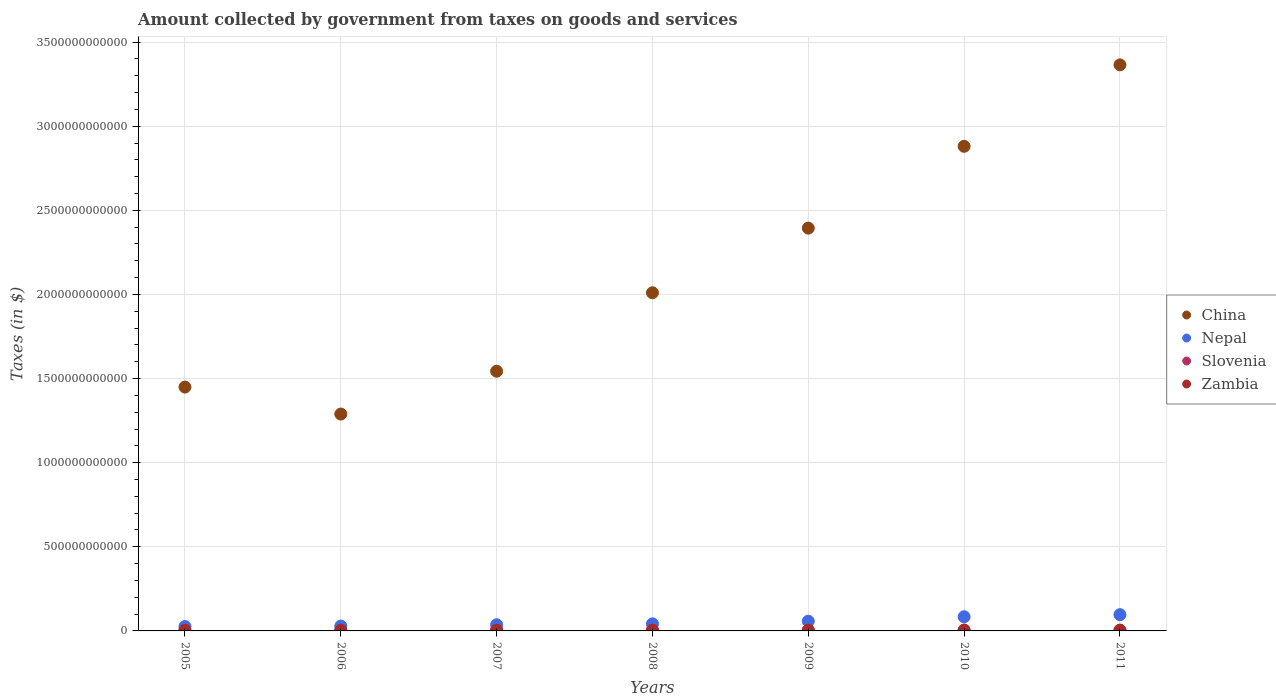What is the amount collected by government from taxes on goods and services in China in 2006?
Keep it short and to the point. 1.29e+12. Across all years, what is the maximum amount collected by government from taxes on goods and services in Slovenia?
Ensure brevity in your answer.  4.73e+09. Across all years, what is the minimum amount collected by government from taxes on goods and services in Nepal?
Give a very brief answer. 2.61e+1. In which year was the amount collected by government from taxes on goods and services in Nepal maximum?
Ensure brevity in your answer.  2011. What is the total amount collected by government from taxes on goods and services in Zambia in the graph?
Make the answer very short. 2.54e+1. What is the difference between the amount collected by government from taxes on goods and services in Zambia in 2010 and that in 2011?
Give a very brief answer. 9.21e+08. What is the difference between the amount collected by government from taxes on goods and services in China in 2011 and the amount collected by government from taxes on goods and services in Zambia in 2005?
Ensure brevity in your answer.  3.36e+12. What is the average amount collected by government from taxes on goods and services in Slovenia per year?
Give a very brief answer. 4.39e+09. In the year 2005, what is the difference between the amount collected by government from taxes on goods and services in China and amount collected by government from taxes on goods and services in Slovenia?
Your answer should be compact. 1.45e+12. In how many years, is the amount collected by government from taxes on goods and services in Zambia greater than 2800000000000 $?
Offer a very short reply. 0. What is the ratio of the amount collected by government from taxes on goods and services in China in 2005 to that in 2009?
Your answer should be very brief. 0.61. Is the amount collected by government from taxes on goods and services in Zambia in 2005 less than that in 2008?
Make the answer very short. Yes. What is the difference between the highest and the second highest amount collected by government from taxes on goods and services in China?
Ensure brevity in your answer.  4.84e+11. What is the difference between the highest and the lowest amount collected by government from taxes on goods and services in Nepal?
Your response must be concise. 7.05e+1. Is the sum of the amount collected by government from taxes on goods and services in Zambia in 2005 and 2008 greater than the maximum amount collected by government from taxes on goods and services in China across all years?
Your answer should be very brief. No. Is it the case that in every year, the sum of the amount collected by government from taxes on goods and services in China and amount collected by government from taxes on goods and services in Nepal  is greater than the sum of amount collected by government from taxes on goods and services in Zambia and amount collected by government from taxes on goods and services in Slovenia?
Give a very brief answer. Yes. Is the amount collected by government from taxes on goods and services in Nepal strictly less than the amount collected by government from taxes on goods and services in Slovenia over the years?
Offer a terse response. No. How many years are there in the graph?
Offer a terse response. 7. What is the difference between two consecutive major ticks on the Y-axis?
Your answer should be compact. 5.00e+11. Are the values on the major ticks of Y-axis written in scientific E-notation?
Your answer should be compact. No. Does the graph contain grids?
Provide a short and direct response. Yes. Where does the legend appear in the graph?
Ensure brevity in your answer.  Center right. How many legend labels are there?
Offer a very short reply. 4. What is the title of the graph?
Provide a short and direct response. Amount collected by government from taxes on goods and services. What is the label or title of the X-axis?
Your answer should be compact. Years. What is the label or title of the Y-axis?
Make the answer very short. Taxes (in $). What is the Taxes (in $) of China in 2005?
Your answer should be compact. 1.45e+12. What is the Taxes (in $) in Nepal in 2005?
Ensure brevity in your answer.  2.61e+1. What is the Taxes (in $) of Slovenia in 2005?
Provide a succinct answer. 3.78e+09. What is the Taxes (in $) of Zambia in 2005?
Offer a terse response. 2.34e+09. What is the Taxes (in $) of China in 2006?
Ensure brevity in your answer.  1.29e+12. What is the Taxes (in $) in Nepal in 2006?
Your answer should be very brief. 2.90e+1. What is the Taxes (in $) of Slovenia in 2006?
Offer a terse response. 3.95e+09. What is the Taxes (in $) of Zambia in 2006?
Your answer should be compact. 2.66e+09. What is the Taxes (in $) of China in 2007?
Your answer should be compact. 1.54e+12. What is the Taxes (in $) in Nepal in 2007?
Your answer should be compact. 3.64e+1. What is the Taxes (in $) of Slovenia in 2007?
Your answer should be very brief. 4.37e+09. What is the Taxes (in $) in Zambia in 2007?
Provide a short and direct response. 3.62e+09. What is the Taxes (in $) of China in 2008?
Provide a short and direct response. 2.01e+12. What is the Taxes (in $) in Nepal in 2008?
Provide a short and direct response. 4.21e+1. What is the Taxes (in $) in Slovenia in 2008?
Offer a terse response. 4.67e+09. What is the Taxes (in $) of Zambia in 2008?
Provide a succinct answer. 4.11e+09. What is the Taxes (in $) of China in 2009?
Ensure brevity in your answer.  2.39e+12. What is the Taxes (in $) of Nepal in 2009?
Your response must be concise. 5.78e+1. What is the Taxes (in $) of Slovenia in 2009?
Your answer should be compact. 4.54e+09. What is the Taxes (in $) of Zambia in 2009?
Offer a very short reply. 3.82e+09. What is the Taxes (in $) of China in 2010?
Make the answer very short. 2.88e+12. What is the Taxes (in $) of Nepal in 2010?
Offer a terse response. 8.42e+1. What is the Taxes (in $) in Slovenia in 2010?
Make the answer very short. 4.66e+09. What is the Taxes (in $) of Zambia in 2010?
Keep it short and to the point. 4.90e+09. What is the Taxes (in $) of China in 2011?
Ensure brevity in your answer.  3.36e+12. What is the Taxes (in $) of Nepal in 2011?
Give a very brief answer. 9.67e+1. What is the Taxes (in $) in Slovenia in 2011?
Your answer should be compact. 4.73e+09. What is the Taxes (in $) in Zambia in 2011?
Your answer should be very brief. 3.98e+09. Across all years, what is the maximum Taxes (in $) in China?
Ensure brevity in your answer.  3.36e+12. Across all years, what is the maximum Taxes (in $) in Nepal?
Ensure brevity in your answer.  9.67e+1. Across all years, what is the maximum Taxes (in $) in Slovenia?
Make the answer very short. 4.73e+09. Across all years, what is the maximum Taxes (in $) of Zambia?
Make the answer very short. 4.90e+09. Across all years, what is the minimum Taxes (in $) of China?
Your answer should be very brief. 1.29e+12. Across all years, what is the minimum Taxes (in $) of Nepal?
Make the answer very short. 2.61e+1. Across all years, what is the minimum Taxes (in $) of Slovenia?
Ensure brevity in your answer.  3.78e+09. Across all years, what is the minimum Taxes (in $) of Zambia?
Offer a terse response. 2.34e+09. What is the total Taxes (in $) in China in the graph?
Make the answer very short. 1.49e+13. What is the total Taxes (in $) in Nepal in the graph?
Keep it short and to the point. 3.72e+11. What is the total Taxes (in $) of Slovenia in the graph?
Your answer should be compact. 3.07e+1. What is the total Taxes (in $) of Zambia in the graph?
Your response must be concise. 2.54e+1. What is the difference between the Taxes (in $) of China in 2005 and that in 2006?
Your response must be concise. 1.60e+11. What is the difference between the Taxes (in $) of Nepal in 2005 and that in 2006?
Give a very brief answer. -2.83e+09. What is the difference between the Taxes (in $) in Slovenia in 2005 and that in 2006?
Ensure brevity in your answer.  -1.67e+08. What is the difference between the Taxes (in $) in Zambia in 2005 and that in 2006?
Make the answer very short. -3.15e+08. What is the difference between the Taxes (in $) of China in 2005 and that in 2007?
Ensure brevity in your answer.  -9.43e+1. What is the difference between the Taxes (in $) in Nepal in 2005 and that in 2007?
Give a very brief answer. -1.03e+1. What is the difference between the Taxes (in $) in Slovenia in 2005 and that in 2007?
Your response must be concise. -5.90e+08. What is the difference between the Taxes (in $) in Zambia in 2005 and that in 2007?
Offer a very short reply. -1.28e+09. What is the difference between the Taxes (in $) in China in 2005 and that in 2008?
Provide a succinct answer. -5.61e+11. What is the difference between the Taxes (in $) in Nepal in 2005 and that in 2008?
Give a very brief answer. -1.59e+1. What is the difference between the Taxes (in $) of Slovenia in 2005 and that in 2008?
Give a very brief answer. -8.86e+08. What is the difference between the Taxes (in $) of Zambia in 2005 and that in 2008?
Your answer should be compact. -1.77e+09. What is the difference between the Taxes (in $) of China in 2005 and that in 2009?
Your answer should be very brief. -9.45e+11. What is the difference between the Taxes (in $) in Nepal in 2005 and that in 2009?
Provide a short and direct response. -3.16e+1. What is the difference between the Taxes (in $) of Slovenia in 2005 and that in 2009?
Make the answer very short. -7.59e+08. What is the difference between the Taxes (in $) in Zambia in 2005 and that in 2009?
Your answer should be compact. -1.48e+09. What is the difference between the Taxes (in $) in China in 2005 and that in 2010?
Give a very brief answer. -1.43e+12. What is the difference between the Taxes (in $) of Nepal in 2005 and that in 2010?
Provide a succinct answer. -5.80e+1. What is the difference between the Taxes (in $) of Slovenia in 2005 and that in 2010?
Offer a terse response. -8.77e+08. What is the difference between the Taxes (in $) in Zambia in 2005 and that in 2010?
Give a very brief answer. -2.56e+09. What is the difference between the Taxes (in $) in China in 2005 and that in 2011?
Your answer should be very brief. -1.92e+12. What is the difference between the Taxes (in $) of Nepal in 2005 and that in 2011?
Your response must be concise. -7.05e+1. What is the difference between the Taxes (in $) in Slovenia in 2005 and that in 2011?
Keep it short and to the point. -9.50e+08. What is the difference between the Taxes (in $) in Zambia in 2005 and that in 2011?
Your answer should be compact. -1.64e+09. What is the difference between the Taxes (in $) in China in 2006 and that in 2007?
Your response must be concise. -2.55e+11. What is the difference between the Taxes (in $) in Nepal in 2006 and that in 2007?
Your answer should be compact. -7.46e+09. What is the difference between the Taxes (in $) in Slovenia in 2006 and that in 2007?
Offer a very short reply. -4.23e+08. What is the difference between the Taxes (in $) in Zambia in 2006 and that in 2007?
Give a very brief answer. -9.62e+08. What is the difference between the Taxes (in $) in China in 2006 and that in 2008?
Offer a terse response. -7.21e+11. What is the difference between the Taxes (in $) in Nepal in 2006 and that in 2008?
Your answer should be very brief. -1.31e+1. What is the difference between the Taxes (in $) of Slovenia in 2006 and that in 2008?
Provide a short and direct response. -7.19e+08. What is the difference between the Taxes (in $) in Zambia in 2006 and that in 2008?
Give a very brief answer. -1.46e+09. What is the difference between the Taxes (in $) of China in 2006 and that in 2009?
Your answer should be very brief. -1.11e+12. What is the difference between the Taxes (in $) of Nepal in 2006 and that in 2009?
Ensure brevity in your answer.  -2.88e+1. What is the difference between the Taxes (in $) in Slovenia in 2006 and that in 2009?
Make the answer very short. -5.92e+08. What is the difference between the Taxes (in $) of Zambia in 2006 and that in 2009?
Make the answer very short. -1.17e+09. What is the difference between the Taxes (in $) of China in 2006 and that in 2010?
Provide a short and direct response. -1.59e+12. What is the difference between the Taxes (in $) of Nepal in 2006 and that in 2010?
Give a very brief answer. -5.52e+1. What is the difference between the Taxes (in $) of Slovenia in 2006 and that in 2010?
Offer a very short reply. -7.09e+08. What is the difference between the Taxes (in $) in Zambia in 2006 and that in 2010?
Your answer should be very brief. -2.24e+09. What is the difference between the Taxes (in $) in China in 2006 and that in 2011?
Your response must be concise. -2.08e+12. What is the difference between the Taxes (in $) in Nepal in 2006 and that in 2011?
Your response must be concise. -6.77e+1. What is the difference between the Taxes (in $) of Slovenia in 2006 and that in 2011?
Offer a terse response. -7.83e+08. What is the difference between the Taxes (in $) in Zambia in 2006 and that in 2011?
Give a very brief answer. -1.32e+09. What is the difference between the Taxes (in $) of China in 2007 and that in 2008?
Provide a short and direct response. -4.66e+11. What is the difference between the Taxes (in $) in Nepal in 2007 and that in 2008?
Provide a short and direct response. -5.64e+09. What is the difference between the Taxes (in $) in Slovenia in 2007 and that in 2008?
Ensure brevity in your answer.  -2.96e+08. What is the difference between the Taxes (in $) of Zambia in 2007 and that in 2008?
Provide a succinct answer. -4.95e+08. What is the difference between the Taxes (in $) of China in 2007 and that in 2009?
Provide a succinct answer. -8.50e+11. What is the difference between the Taxes (in $) in Nepal in 2007 and that in 2009?
Your answer should be very brief. -2.13e+1. What is the difference between the Taxes (in $) of Slovenia in 2007 and that in 2009?
Provide a succinct answer. -1.69e+08. What is the difference between the Taxes (in $) in Zambia in 2007 and that in 2009?
Your answer should be compact. -2.04e+08. What is the difference between the Taxes (in $) in China in 2007 and that in 2010?
Make the answer very short. -1.34e+12. What is the difference between the Taxes (in $) in Nepal in 2007 and that in 2010?
Make the answer very short. -4.77e+1. What is the difference between the Taxes (in $) of Slovenia in 2007 and that in 2010?
Give a very brief answer. -2.86e+08. What is the difference between the Taxes (in $) in Zambia in 2007 and that in 2010?
Offer a very short reply. -1.28e+09. What is the difference between the Taxes (in $) of China in 2007 and that in 2011?
Your answer should be very brief. -1.82e+12. What is the difference between the Taxes (in $) of Nepal in 2007 and that in 2011?
Offer a terse response. -6.02e+1. What is the difference between the Taxes (in $) of Slovenia in 2007 and that in 2011?
Provide a succinct answer. -3.60e+08. What is the difference between the Taxes (in $) of Zambia in 2007 and that in 2011?
Make the answer very short. -3.62e+08. What is the difference between the Taxes (in $) in China in 2008 and that in 2009?
Your response must be concise. -3.84e+11. What is the difference between the Taxes (in $) in Nepal in 2008 and that in 2009?
Offer a very short reply. -1.57e+1. What is the difference between the Taxes (in $) of Slovenia in 2008 and that in 2009?
Make the answer very short. 1.27e+08. What is the difference between the Taxes (in $) of Zambia in 2008 and that in 2009?
Ensure brevity in your answer.  2.91e+08. What is the difference between the Taxes (in $) in China in 2008 and that in 2010?
Ensure brevity in your answer.  -8.70e+11. What is the difference between the Taxes (in $) in Nepal in 2008 and that in 2010?
Give a very brief answer. -4.21e+1. What is the difference between the Taxes (in $) in Slovenia in 2008 and that in 2010?
Provide a succinct answer. 9.21e+06. What is the difference between the Taxes (in $) of Zambia in 2008 and that in 2010?
Your answer should be very brief. -7.88e+08. What is the difference between the Taxes (in $) of China in 2008 and that in 2011?
Ensure brevity in your answer.  -1.35e+12. What is the difference between the Taxes (in $) of Nepal in 2008 and that in 2011?
Offer a terse response. -5.46e+1. What is the difference between the Taxes (in $) in Slovenia in 2008 and that in 2011?
Your answer should be compact. -6.41e+07. What is the difference between the Taxes (in $) of Zambia in 2008 and that in 2011?
Keep it short and to the point. 1.33e+08. What is the difference between the Taxes (in $) of China in 2009 and that in 2010?
Your response must be concise. -4.86e+11. What is the difference between the Taxes (in $) in Nepal in 2009 and that in 2010?
Ensure brevity in your answer.  -2.64e+1. What is the difference between the Taxes (in $) of Slovenia in 2009 and that in 2010?
Offer a terse response. -1.17e+08. What is the difference between the Taxes (in $) of Zambia in 2009 and that in 2010?
Provide a short and direct response. -1.08e+09. What is the difference between the Taxes (in $) in China in 2009 and that in 2011?
Offer a very short reply. -9.71e+11. What is the difference between the Taxes (in $) of Nepal in 2009 and that in 2011?
Your response must be concise. -3.89e+1. What is the difference between the Taxes (in $) in Slovenia in 2009 and that in 2011?
Your answer should be compact. -1.91e+08. What is the difference between the Taxes (in $) of Zambia in 2009 and that in 2011?
Keep it short and to the point. -1.58e+08. What is the difference between the Taxes (in $) in China in 2010 and that in 2011?
Provide a short and direct response. -4.84e+11. What is the difference between the Taxes (in $) of Nepal in 2010 and that in 2011?
Provide a succinct answer. -1.25e+1. What is the difference between the Taxes (in $) of Slovenia in 2010 and that in 2011?
Provide a succinct answer. -7.33e+07. What is the difference between the Taxes (in $) of Zambia in 2010 and that in 2011?
Your answer should be compact. 9.21e+08. What is the difference between the Taxes (in $) in China in 2005 and the Taxes (in $) in Nepal in 2006?
Offer a terse response. 1.42e+12. What is the difference between the Taxes (in $) of China in 2005 and the Taxes (in $) of Slovenia in 2006?
Ensure brevity in your answer.  1.45e+12. What is the difference between the Taxes (in $) of China in 2005 and the Taxes (in $) of Zambia in 2006?
Keep it short and to the point. 1.45e+12. What is the difference between the Taxes (in $) of Nepal in 2005 and the Taxes (in $) of Slovenia in 2006?
Provide a succinct answer. 2.22e+1. What is the difference between the Taxes (in $) in Nepal in 2005 and the Taxes (in $) in Zambia in 2006?
Your answer should be compact. 2.35e+1. What is the difference between the Taxes (in $) in Slovenia in 2005 and the Taxes (in $) in Zambia in 2006?
Your answer should be very brief. 1.13e+09. What is the difference between the Taxes (in $) in China in 2005 and the Taxes (in $) in Nepal in 2007?
Make the answer very short. 1.41e+12. What is the difference between the Taxes (in $) of China in 2005 and the Taxes (in $) of Slovenia in 2007?
Offer a terse response. 1.45e+12. What is the difference between the Taxes (in $) in China in 2005 and the Taxes (in $) in Zambia in 2007?
Provide a succinct answer. 1.45e+12. What is the difference between the Taxes (in $) of Nepal in 2005 and the Taxes (in $) of Slovenia in 2007?
Your answer should be very brief. 2.18e+1. What is the difference between the Taxes (in $) in Nepal in 2005 and the Taxes (in $) in Zambia in 2007?
Ensure brevity in your answer.  2.25e+1. What is the difference between the Taxes (in $) in Slovenia in 2005 and the Taxes (in $) in Zambia in 2007?
Keep it short and to the point. 1.65e+08. What is the difference between the Taxes (in $) in China in 2005 and the Taxes (in $) in Nepal in 2008?
Make the answer very short. 1.41e+12. What is the difference between the Taxes (in $) in China in 2005 and the Taxes (in $) in Slovenia in 2008?
Keep it short and to the point. 1.44e+12. What is the difference between the Taxes (in $) in China in 2005 and the Taxes (in $) in Zambia in 2008?
Keep it short and to the point. 1.45e+12. What is the difference between the Taxes (in $) of Nepal in 2005 and the Taxes (in $) of Slovenia in 2008?
Keep it short and to the point. 2.15e+1. What is the difference between the Taxes (in $) in Nepal in 2005 and the Taxes (in $) in Zambia in 2008?
Offer a very short reply. 2.20e+1. What is the difference between the Taxes (in $) in Slovenia in 2005 and the Taxes (in $) in Zambia in 2008?
Offer a very short reply. -3.30e+08. What is the difference between the Taxes (in $) in China in 2005 and the Taxes (in $) in Nepal in 2009?
Provide a succinct answer. 1.39e+12. What is the difference between the Taxes (in $) in China in 2005 and the Taxes (in $) in Slovenia in 2009?
Your answer should be very brief. 1.44e+12. What is the difference between the Taxes (in $) in China in 2005 and the Taxes (in $) in Zambia in 2009?
Ensure brevity in your answer.  1.45e+12. What is the difference between the Taxes (in $) of Nepal in 2005 and the Taxes (in $) of Slovenia in 2009?
Make the answer very short. 2.16e+1. What is the difference between the Taxes (in $) in Nepal in 2005 and the Taxes (in $) in Zambia in 2009?
Ensure brevity in your answer.  2.23e+1. What is the difference between the Taxes (in $) of Slovenia in 2005 and the Taxes (in $) of Zambia in 2009?
Your response must be concise. -3.88e+07. What is the difference between the Taxes (in $) in China in 2005 and the Taxes (in $) in Nepal in 2010?
Keep it short and to the point. 1.37e+12. What is the difference between the Taxes (in $) in China in 2005 and the Taxes (in $) in Slovenia in 2010?
Your answer should be compact. 1.44e+12. What is the difference between the Taxes (in $) in China in 2005 and the Taxes (in $) in Zambia in 2010?
Keep it short and to the point. 1.44e+12. What is the difference between the Taxes (in $) of Nepal in 2005 and the Taxes (in $) of Slovenia in 2010?
Offer a very short reply. 2.15e+1. What is the difference between the Taxes (in $) of Nepal in 2005 and the Taxes (in $) of Zambia in 2010?
Keep it short and to the point. 2.12e+1. What is the difference between the Taxes (in $) in Slovenia in 2005 and the Taxes (in $) in Zambia in 2010?
Offer a terse response. -1.12e+09. What is the difference between the Taxes (in $) in China in 2005 and the Taxes (in $) in Nepal in 2011?
Provide a succinct answer. 1.35e+12. What is the difference between the Taxes (in $) in China in 2005 and the Taxes (in $) in Slovenia in 2011?
Your answer should be very brief. 1.44e+12. What is the difference between the Taxes (in $) in China in 2005 and the Taxes (in $) in Zambia in 2011?
Provide a short and direct response. 1.45e+12. What is the difference between the Taxes (in $) of Nepal in 2005 and the Taxes (in $) of Slovenia in 2011?
Your answer should be compact. 2.14e+1. What is the difference between the Taxes (in $) in Nepal in 2005 and the Taxes (in $) in Zambia in 2011?
Provide a short and direct response. 2.22e+1. What is the difference between the Taxes (in $) in Slovenia in 2005 and the Taxes (in $) in Zambia in 2011?
Give a very brief answer. -1.96e+08. What is the difference between the Taxes (in $) in China in 2006 and the Taxes (in $) in Nepal in 2007?
Give a very brief answer. 1.25e+12. What is the difference between the Taxes (in $) in China in 2006 and the Taxes (in $) in Slovenia in 2007?
Ensure brevity in your answer.  1.28e+12. What is the difference between the Taxes (in $) in China in 2006 and the Taxes (in $) in Zambia in 2007?
Offer a terse response. 1.29e+12. What is the difference between the Taxes (in $) of Nepal in 2006 and the Taxes (in $) of Slovenia in 2007?
Provide a short and direct response. 2.46e+1. What is the difference between the Taxes (in $) in Nepal in 2006 and the Taxes (in $) in Zambia in 2007?
Your response must be concise. 2.54e+1. What is the difference between the Taxes (in $) in Slovenia in 2006 and the Taxes (in $) in Zambia in 2007?
Provide a succinct answer. 3.33e+08. What is the difference between the Taxes (in $) of China in 2006 and the Taxes (in $) of Nepal in 2008?
Offer a very short reply. 1.25e+12. What is the difference between the Taxes (in $) in China in 2006 and the Taxes (in $) in Slovenia in 2008?
Offer a terse response. 1.28e+12. What is the difference between the Taxes (in $) of China in 2006 and the Taxes (in $) of Zambia in 2008?
Offer a terse response. 1.28e+12. What is the difference between the Taxes (in $) of Nepal in 2006 and the Taxes (in $) of Slovenia in 2008?
Ensure brevity in your answer.  2.43e+1. What is the difference between the Taxes (in $) in Nepal in 2006 and the Taxes (in $) in Zambia in 2008?
Ensure brevity in your answer.  2.49e+1. What is the difference between the Taxes (in $) in Slovenia in 2006 and the Taxes (in $) in Zambia in 2008?
Give a very brief answer. -1.62e+08. What is the difference between the Taxes (in $) in China in 2006 and the Taxes (in $) in Nepal in 2009?
Your answer should be compact. 1.23e+12. What is the difference between the Taxes (in $) of China in 2006 and the Taxes (in $) of Slovenia in 2009?
Your response must be concise. 1.28e+12. What is the difference between the Taxes (in $) of China in 2006 and the Taxes (in $) of Zambia in 2009?
Your answer should be compact. 1.29e+12. What is the difference between the Taxes (in $) in Nepal in 2006 and the Taxes (in $) in Slovenia in 2009?
Keep it short and to the point. 2.44e+1. What is the difference between the Taxes (in $) of Nepal in 2006 and the Taxes (in $) of Zambia in 2009?
Your response must be concise. 2.51e+1. What is the difference between the Taxes (in $) in Slovenia in 2006 and the Taxes (in $) in Zambia in 2009?
Offer a terse response. 1.29e+08. What is the difference between the Taxes (in $) in China in 2006 and the Taxes (in $) in Nepal in 2010?
Your answer should be very brief. 1.20e+12. What is the difference between the Taxes (in $) of China in 2006 and the Taxes (in $) of Slovenia in 2010?
Give a very brief answer. 1.28e+12. What is the difference between the Taxes (in $) of China in 2006 and the Taxes (in $) of Zambia in 2010?
Give a very brief answer. 1.28e+12. What is the difference between the Taxes (in $) in Nepal in 2006 and the Taxes (in $) in Slovenia in 2010?
Give a very brief answer. 2.43e+1. What is the difference between the Taxes (in $) in Nepal in 2006 and the Taxes (in $) in Zambia in 2010?
Give a very brief answer. 2.41e+1. What is the difference between the Taxes (in $) in Slovenia in 2006 and the Taxes (in $) in Zambia in 2010?
Provide a short and direct response. -9.50e+08. What is the difference between the Taxes (in $) of China in 2006 and the Taxes (in $) of Nepal in 2011?
Give a very brief answer. 1.19e+12. What is the difference between the Taxes (in $) of China in 2006 and the Taxes (in $) of Slovenia in 2011?
Offer a terse response. 1.28e+12. What is the difference between the Taxes (in $) in China in 2006 and the Taxes (in $) in Zambia in 2011?
Keep it short and to the point. 1.29e+12. What is the difference between the Taxes (in $) of Nepal in 2006 and the Taxes (in $) of Slovenia in 2011?
Your answer should be very brief. 2.42e+1. What is the difference between the Taxes (in $) of Nepal in 2006 and the Taxes (in $) of Zambia in 2011?
Your answer should be compact. 2.50e+1. What is the difference between the Taxes (in $) of Slovenia in 2006 and the Taxes (in $) of Zambia in 2011?
Ensure brevity in your answer.  -2.91e+07. What is the difference between the Taxes (in $) of China in 2007 and the Taxes (in $) of Nepal in 2008?
Give a very brief answer. 1.50e+12. What is the difference between the Taxes (in $) of China in 2007 and the Taxes (in $) of Slovenia in 2008?
Keep it short and to the point. 1.54e+12. What is the difference between the Taxes (in $) in China in 2007 and the Taxes (in $) in Zambia in 2008?
Offer a terse response. 1.54e+12. What is the difference between the Taxes (in $) of Nepal in 2007 and the Taxes (in $) of Slovenia in 2008?
Provide a succinct answer. 3.18e+1. What is the difference between the Taxes (in $) in Nepal in 2007 and the Taxes (in $) in Zambia in 2008?
Offer a terse response. 3.23e+1. What is the difference between the Taxes (in $) in Slovenia in 2007 and the Taxes (in $) in Zambia in 2008?
Offer a very short reply. 2.61e+08. What is the difference between the Taxes (in $) of China in 2007 and the Taxes (in $) of Nepal in 2009?
Your answer should be compact. 1.49e+12. What is the difference between the Taxes (in $) in China in 2007 and the Taxes (in $) in Slovenia in 2009?
Offer a very short reply. 1.54e+12. What is the difference between the Taxes (in $) in China in 2007 and the Taxes (in $) in Zambia in 2009?
Offer a very short reply. 1.54e+12. What is the difference between the Taxes (in $) in Nepal in 2007 and the Taxes (in $) in Slovenia in 2009?
Your answer should be compact. 3.19e+1. What is the difference between the Taxes (in $) of Nepal in 2007 and the Taxes (in $) of Zambia in 2009?
Offer a very short reply. 3.26e+1. What is the difference between the Taxes (in $) in Slovenia in 2007 and the Taxes (in $) in Zambia in 2009?
Your answer should be very brief. 5.52e+08. What is the difference between the Taxes (in $) in China in 2007 and the Taxes (in $) in Nepal in 2010?
Give a very brief answer. 1.46e+12. What is the difference between the Taxes (in $) of China in 2007 and the Taxes (in $) of Slovenia in 2010?
Give a very brief answer. 1.54e+12. What is the difference between the Taxes (in $) in China in 2007 and the Taxes (in $) in Zambia in 2010?
Make the answer very short. 1.54e+12. What is the difference between the Taxes (in $) in Nepal in 2007 and the Taxes (in $) in Slovenia in 2010?
Offer a terse response. 3.18e+1. What is the difference between the Taxes (in $) of Nepal in 2007 and the Taxes (in $) of Zambia in 2010?
Ensure brevity in your answer.  3.15e+1. What is the difference between the Taxes (in $) of Slovenia in 2007 and the Taxes (in $) of Zambia in 2010?
Offer a terse response. -5.27e+08. What is the difference between the Taxes (in $) of China in 2007 and the Taxes (in $) of Nepal in 2011?
Your response must be concise. 1.45e+12. What is the difference between the Taxes (in $) in China in 2007 and the Taxes (in $) in Slovenia in 2011?
Your answer should be very brief. 1.54e+12. What is the difference between the Taxes (in $) of China in 2007 and the Taxes (in $) of Zambia in 2011?
Keep it short and to the point. 1.54e+12. What is the difference between the Taxes (in $) in Nepal in 2007 and the Taxes (in $) in Slovenia in 2011?
Keep it short and to the point. 3.17e+1. What is the difference between the Taxes (in $) in Nepal in 2007 and the Taxes (in $) in Zambia in 2011?
Your response must be concise. 3.25e+1. What is the difference between the Taxes (in $) in Slovenia in 2007 and the Taxes (in $) in Zambia in 2011?
Your answer should be very brief. 3.94e+08. What is the difference between the Taxes (in $) in China in 2008 and the Taxes (in $) in Nepal in 2009?
Your answer should be very brief. 1.95e+12. What is the difference between the Taxes (in $) in China in 2008 and the Taxes (in $) in Slovenia in 2009?
Your response must be concise. 2.01e+12. What is the difference between the Taxes (in $) in China in 2008 and the Taxes (in $) in Zambia in 2009?
Keep it short and to the point. 2.01e+12. What is the difference between the Taxes (in $) in Nepal in 2008 and the Taxes (in $) in Slovenia in 2009?
Provide a succinct answer. 3.75e+1. What is the difference between the Taxes (in $) of Nepal in 2008 and the Taxes (in $) of Zambia in 2009?
Your answer should be very brief. 3.83e+1. What is the difference between the Taxes (in $) in Slovenia in 2008 and the Taxes (in $) in Zambia in 2009?
Make the answer very short. 8.47e+08. What is the difference between the Taxes (in $) in China in 2008 and the Taxes (in $) in Nepal in 2010?
Your response must be concise. 1.93e+12. What is the difference between the Taxes (in $) in China in 2008 and the Taxes (in $) in Slovenia in 2010?
Provide a succinct answer. 2.01e+12. What is the difference between the Taxes (in $) of China in 2008 and the Taxes (in $) of Zambia in 2010?
Make the answer very short. 2.01e+12. What is the difference between the Taxes (in $) in Nepal in 2008 and the Taxes (in $) in Slovenia in 2010?
Provide a short and direct response. 3.74e+1. What is the difference between the Taxes (in $) of Nepal in 2008 and the Taxes (in $) of Zambia in 2010?
Your response must be concise. 3.72e+1. What is the difference between the Taxes (in $) of Slovenia in 2008 and the Taxes (in $) of Zambia in 2010?
Offer a terse response. -2.32e+08. What is the difference between the Taxes (in $) of China in 2008 and the Taxes (in $) of Nepal in 2011?
Provide a succinct answer. 1.91e+12. What is the difference between the Taxes (in $) of China in 2008 and the Taxes (in $) of Slovenia in 2011?
Provide a short and direct response. 2.01e+12. What is the difference between the Taxes (in $) of China in 2008 and the Taxes (in $) of Zambia in 2011?
Give a very brief answer. 2.01e+12. What is the difference between the Taxes (in $) of Nepal in 2008 and the Taxes (in $) of Slovenia in 2011?
Ensure brevity in your answer.  3.73e+1. What is the difference between the Taxes (in $) of Nepal in 2008 and the Taxes (in $) of Zambia in 2011?
Your answer should be compact. 3.81e+1. What is the difference between the Taxes (in $) in Slovenia in 2008 and the Taxes (in $) in Zambia in 2011?
Keep it short and to the point. 6.90e+08. What is the difference between the Taxes (in $) in China in 2009 and the Taxes (in $) in Nepal in 2010?
Keep it short and to the point. 2.31e+12. What is the difference between the Taxes (in $) of China in 2009 and the Taxes (in $) of Slovenia in 2010?
Offer a terse response. 2.39e+12. What is the difference between the Taxes (in $) in China in 2009 and the Taxes (in $) in Zambia in 2010?
Keep it short and to the point. 2.39e+12. What is the difference between the Taxes (in $) in Nepal in 2009 and the Taxes (in $) in Slovenia in 2010?
Make the answer very short. 5.31e+1. What is the difference between the Taxes (in $) of Nepal in 2009 and the Taxes (in $) of Zambia in 2010?
Provide a short and direct response. 5.29e+1. What is the difference between the Taxes (in $) in Slovenia in 2009 and the Taxes (in $) in Zambia in 2010?
Make the answer very short. -3.58e+08. What is the difference between the Taxes (in $) of China in 2009 and the Taxes (in $) of Nepal in 2011?
Provide a short and direct response. 2.30e+12. What is the difference between the Taxes (in $) of China in 2009 and the Taxes (in $) of Slovenia in 2011?
Provide a succinct answer. 2.39e+12. What is the difference between the Taxes (in $) of China in 2009 and the Taxes (in $) of Zambia in 2011?
Keep it short and to the point. 2.39e+12. What is the difference between the Taxes (in $) in Nepal in 2009 and the Taxes (in $) in Slovenia in 2011?
Offer a terse response. 5.30e+1. What is the difference between the Taxes (in $) in Nepal in 2009 and the Taxes (in $) in Zambia in 2011?
Your answer should be compact. 5.38e+1. What is the difference between the Taxes (in $) in Slovenia in 2009 and the Taxes (in $) in Zambia in 2011?
Your answer should be compact. 5.63e+08. What is the difference between the Taxes (in $) in China in 2010 and the Taxes (in $) in Nepal in 2011?
Give a very brief answer. 2.78e+12. What is the difference between the Taxes (in $) in China in 2010 and the Taxes (in $) in Slovenia in 2011?
Keep it short and to the point. 2.88e+12. What is the difference between the Taxes (in $) in China in 2010 and the Taxes (in $) in Zambia in 2011?
Make the answer very short. 2.88e+12. What is the difference between the Taxes (in $) of Nepal in 2010 and the Taxes (in $) of Slovenia in 2011?
Your answer should be very brief. 7.94e+1. What is the difference between the Taxes (in $) in Nepal in 2010 and the Taxes (in $) in Zambia in 2011?
Make the answer very short. 8.02e+1. What is the difference between the Taxes (in $) of Slovenia in 2010 and the Taxes (in $) of Zambia in 2011?
Give a very brief answer. 6.80e+08. What is the average Taxes (in $) in China per year?
Ensure brevity in your answer.  2.13e+12. What is the average Taxes (in $) in Nepal per year?
Give a very brief answer. 5.32e+1. What is the average Taxes (in $) in Slovenia per year?
Offer a very short reply. 4.39e+09. What is the average Taxes (in $) in Zambia per year?
Keep it short and to the point. 3.63e+09. In the year 2005, what is the difference between the Taxes (in $) of China and Taxes (in $) of Nepal?
Your answer should be compact. 1.42e+12. In the year 2005, what is the difference between the Taxes (in $) in China and Taxes (in $) in Slovenia?
Your answer should be very brief. 1.45e+12. In the year 2005, what is the difference between the Taxes (in $) in China and Taxes (in $) in Zambia?
Your answer should be very brief. 1.45e+12. In the year 2005, what is the difference between the Taxes (in $) of Nepal and Taxes (in $) of Slovenia?
Keep it short and to the point. 2.24e+1. In the year 2005, what is the difference between the Taxes (in $) in Nepal and Taxes (in $) in Zambia?
Offer a very short reply. 2.38e+1. In the year 2005, what is the difference between the Taxes (in $) of Slovenia and Taxes (in $) of Zambia?
Make the answer very short. 1.44e+09. In the year 2006, what is the difference between the Taxes (in $) in China and Taxes (in $) in Nepal?
Your answer should be very brief. 1.26e+12. In the year 2006, what is the difference between the Taxes (in $) in China and Taxes (in $) in Slovenia?
Offer a very short reply. 1.29e+12. In the year 2006, what is the difference between the Taxes (in $) in China and Taxes (in $) in Zambia?
Ensure brevity in your answer.  1.29e+12. In the year 2006, what is the difference between the Taxes (in $) of Nepal and Taxes (in $) of Slovenia?
Ensure brevity in your answer.  2.50e+1. In the year 2006, what is the difference between the Taxes (in $) in Nepal and Taxes (in $) in Zambia?
Your response must be concise. 2.63e+1. In the year 2006, what is the difference between the Taxes (in $) in Slovenia and Taxes (in $) in Zambia?
Your answer should be very brief. 1.29e+09. In the year 2007, what is the difference between the Taxes (in $) of China and Taxes (in $) of Nepal?
Give a very brief answer. 1.51e+12. In the year 2007, what is the difference between the Taxes (in $) in China and Taxes (in $) in Slovenia?
Make the answer very short. 1.54e+12. In the year 2007, what is the difference between the Taxes (in $) in China and Taxes (in $) in Zambia?
Keep it short and to the point. 1.54e+12. In the year 2007, what is the difference between the Taxes (in $) in Nepal and Taxes (in $) in Slovenia?
Provide a short and direct response. 3.21e+1. In the year 2007, what is the difference between the Taxes (in $) in Nepal and Taxes (in $) in Zambia?
Offer a terse response. 3.28e+1. In the year 2007, what is the difference between the Taxes (in $) in Slovenia and Taxes (in $) in Zambia?
Offer a very short reply. 7.56e+08. In the year 2008, what is the difference between the Taxes (in $) of China and Taxes (in $) of Nepal?
Offer a terse response. 1.97e+12. In the year 2008, what is the difference between the Taxes (in $) of China and Taxes (in $) of Slovenia?
Ensure brevity in your answer.  2.01e+12. In the year 2008, what is the difference between the Taxes (in $) in China and Taxes (in $) in Zambia?
Your answer should be compact. 2.01e+12. In the year 2008, what is the difference between the Taxes (in $) of Nepal and Taxes (in $) of Slovenia?
Keep it short and to the point. 3.74e+1. In the year 2008, what is the difference between the Taxes (in $) in Nepal and Taxes (in $) in Zambia?
Make the answer very short. 3.80e+1. In the year 2008, what is the difference between the Taxes (in $) in Slovenia and Taxes (in $) in Zambia?
Offer a very short reply. 5.56e+08. In the year 2009, what is the difference between the Taxes (in $) of China and Taxes (in $) of Nepal?
Ensure brevity in your answer.  2.34e+12. In the year 2009, what is the difference between the Taxes (in $) of China and Taxes (in $) of Slovenia?
Make the answer very short. 2.39e+12. In the year 2009, what is the difference between the Taxes (in $) of China and Taxes (in $) of Zambia?
Your answer should be compact. 2.39e+12. In the year 2009, what is the difference between the Taxes (in $) in Nepal and Taxes (in $) in Slovenia?
Provide a short and direct response. 5.32e+1. In the year 2009, what is the difference between the Taxes (in $) of Nepal and Taxes (in $) of Zambia?
Your answer should be compact. 5.39e+1. In the year 2009, what is the difference between the Taxes (in $) of Slovenia and Taxes (in $) of Zambia?
Ensure brevity in your answer.  7.20e+08. In the year 2010, what is the difference between the Taxes (in $) in China and Taxes (in $) in Nepal?
Give a very brief answer. 2.80e+12. In the year 2010, what is the difference between the Taxes (in $) of China and Taxes (in $) of Slovenia?
Ensure brevity in your answer.  2.88e+12. In the year 2010, what is the difference between the Taxes (in $) in China and Taxes (in $) in Zambia?
Make the answer very short. 2.88e+12. In the year 2010, what is the difference between the Taxes (in $) of Nepal and Taxes (in $) of Slovenia?
Your response must be concise. 7.95e+1. In the year 2010, what is the difference between the Taxes (in $) of Nepal and Taxes (in $) of Zambia?
Offer a terse response. 7.93e+1. In the year 2010, what is the difference between the Taxes (in $) in Slovenia and Taxes (in $) in Zambia?
Your answer should be very brief. -2.41e+08. In the year 2011, what is the difference between the Taxes (in $) in China and Taxes (in $) in Nepal?
Your answer should be compact. 3.27e+12. In the year 2011, what is the difference between the Taxes (in $) in China and Taxes (in $) in Slovenia?
Your answer should be compact. 3.36e+12. In the year 2011, what is the difference between the Taxes (in $) of China and Taxes (in $) of Zambia?
Offer a terse response. 3.36e+12. In the year 2011, what is the difference between the Taxes (in $) of Nepal and Taxes (in $) of Slovenia?
Offer a terse response. 9.19e+1. In the year 2011, what is the difference between the Taxes (in $) in Nepal and Taxes (in $) in Zambia?
Ensure brevity in your answer.  9.27e+1. In the year 2011, what is the difference between the Taxes (in $) in Slovenia and Taxes (in $) in Zambia?
Make the answer very short. 7.54e+08. What is the ratio of the Taxes (in $) in China in 2005 to that in 2006?
Keep it short and to the point. 1.12. What is the ratio of the Taxes (in $) of Nepal in 2005 to that in 2006?
Offer a terse response. 0.9. What is the ratio of the Taxes (in $) of Slovenia in 2005 to that in 2006?
Provide a succinct answer. 0.96. What is the ratio of the Taxes (in $) in Zambia in 2005 to that in 2006?
Your answer should be very brief. 0.88. What is the ratio of the Taxes (in $) in China in 2005 to that in 2007?
Your answer should be very brief. 0.94. What is the ratio of the Taxes (in $) of Nepal in 2005 to that in 2007?
Your answer should be very brief. 0.72. What is the ratio of the Taxes (in $) in Slovenia in 2005 to that in 2007?
Provide a succinct answer. 0.86. What is the ratio of the Taxes (in $) of Zambia in 2005 to that in 2007?
Your answer should be very brief. 0.65. What is the ratio of the Taxes (in $) of China in 2005 to that in 2008?
Offer a terse response. 0.72. What is the ratio of the Taxes (in $) in Nepal in 2005 to that in 2008?
Make the answer very short. 0.62. What is the ratio of the Taxes (in $) of Slovenia in 2005 to that in 2008?
Ensure brevity in your answer.  0.81. What is the ratio of the Taxes (in $) of Zambia in 2005 to that in 2008?
Offer a very short reply. 0.57. What is the ratio of the Taxes (in $) of China in 2005 to that in 2009?
Offer a terse response. 0.61. What is the ratio of the Taxes (in $) of Nepal in 2005 to that in 2009?
Make the answer very short. 0.45. What is the ratio of the Taxes (in $) of Slovenia in 2005 to that in 2009?
Make the answer very short. 0.83. What is the ratio of the Taxes (in $) of Zambia in 2005 to that in 2009?
Your answer should be very brief. 0.61. What is the ratio of the Taxes (in $) of China in 2005 to that in 2010?
Give a very brief answer. 0.5. What is the ratio of the Taxes (in $) in Nepal in 2005 to that in 2010?
Your answer should be very brief. 0.31. What is the ratio of the Taxes (in $) of Slovenia in 2005 to that in 2010?
Provide a succinct answer. 0.81. What is the ratio of the Taxes (in $) in Zambia in 2005 to that in 2010?
Make the answer very short. 0.48. What is the ratio of the Taxes (in $) in China in 2005 to that in 2011?
Make the answer very short. 0.43. What is the ratio of the Taxes (in $) in Nepal in 2005 to that in 2011?
Keep it short and to the point. 0.27. What is the ratio of the Taxes (in $) of Slovenia in 2005 to that in 2011?
Provide a short and direct response. 0.8. What is the ratio of the Taxes (in $) in Zambia in 2005 to that in 2011?
Offer a very short reply. 0.59. What is the ratio of the Taxes (in $) in China in 2006 to that in 2007?
Provide a short and direct response. 0.84. What is the ratio of the Taxes (in $) in Nepal in 2006 to that in 2007?
Your answer should be compact. 0.8. What is the ratio of the Taxes (in $) of Slovenia in 2006 to that in 2007?
Keep it short and to the point. 0.9. What is the ratio of the Taxes (in $) of Zambia in 2006 to that in 2007?
Keep it short and to the point. 0.73. What is the ratio of the Taxes (in $) in China in 2006 to that in 2008?
Keep it short and to the point. 0.64. What is the ratio of the Taxes (in $) of Nepal in 2006 to that in 2008?
Keep it short and to the point. 0.69. What is the ratio of the Taxes (in $) in Slovenia in 2006 to that in 2008?
Offer a terse response. 0.85. What is the ratio of the Taxes (in $) of Zambia in 2006 to that in 2008?
Your answer should be compact. 0.65. What is the ratio of the Taxes (in $) of China in 2006 to that in 2009?
Offer a very short reply. 0.54. What is the ratio of the Taxes (in $) of Nepal in 2006 to that in 2009?
Your answer should be very brief. 0.5. What is the ratio of the Taxes (in $) of Slovenia in 2006 to that in 2009?
Offer a very short reply. 0.87. What is the ratio of the Taxes (in $) in Zambia in 2006 to that in 2009?
Make the answer very short. 0.69. What is the ratio of the Taxes (in $) in China in 2006 to that in 2010?
Offer a very short reply. 0.45. What is the ratio of the Taxes (in $) in Nepal in 2006 to that in 2010?
Provide a short and direct response. 0.34. What is the ratio of the Taxes (in $) in Slovenia in 2006 to that in 2010?
Your answer should be very brief. 0.85. What is the ratio of the Taxes (in $) in Zambia in 2006 to that in 2010?
Ensure brevity in your answer.  0.54. What is the ratio of the Taxes (in $) in China in 2006 to that in 2011?
Your response must be concise. 0.38. What is the ratio of the Taxes (in $) of Nepal in 2006 to that in 2011?
Keep it short and to the point. 0.3. What is the ratio of the Taxes (in $) in Slovenia in 2006 to that in 2011?
Your answer should be very brief. 0.83. What is the ratio of the Taxes (in $) in Zambia in 2006 to that in 2011?
Your response must be concise. 0.67. What is the ratio of the Taxes (in $) in China in 2007 to that in 2008?
Offer a very short reply. 0.77. What is the ratio of the Taxes (in $) of Nepal in 2007 to that in 2008?
Give a very brief answer. 0.87. What is the ratio of the Taxes (in $) of Slovenia in 2007 to that in 2008?
Offer a very short reply. 0.94. What is the ratio of the Taxes (in $) of Zambia in 2007 to that in 2008?
Offer a very short reply. 0.88. What is the ratio of the Taxes (in $) of China in 2007 to that in 2009?
Provide a succinct answer. 0.64. What is the ratio of the Taxes (in $) of Nepal in 2007 to that in 2009?
Keep it short and to the point. 0.63. What is the ratio of the Taxes (in $) in Slovenia in 2007 to that in 2009?
Your answer should be compact. 0.96. What is the ratio of the Taxes (in $) of Zambia in 2007 to that in 2009?
Ensure brevity in your answer.  0.95. What is the ratio of the Taxes (in $) of China in 2007 to that in 2010?
Offer a very short reply. 0.54. What is the ratio of the Taxes (in $) of Nepal in 2007 to that in 2010?
Your response must be concise. 0.43. What is the ratio of the Taxes (in $) of Slovenia in 2007 to that in 2010?
Give a very brief answer. 0.94. What is the ratio of the Taxes (in $) of Zambia in 2007 to that in 2010?
Your answer should be very brief. 0.74. What is the ratio of the Taxes (in $) of China in 2007 to that in 2011?
Ensure brevity in your answer.  0.46. What is the ratio of the Taxes (in $) in Nepal in 2007 to that in 2011?
Provide a short and direct response. 0.38. What is the ratio of the Taxes (in $) of Slovenia in 2007 to that in 2011?
Ensure brevity in your answer.  0.92. What is the ratio of the Taxes (in $) of Zambia in 2007 to that in 2011?
Your answer should be very brief. 0.91. What is the ratio of the Taxes (in $) of China in 2008 to that in 2009?
Make the answer very short. 0.84. What is the ratio of the Taxes (in $) in Nepal in 2008 to that in 2009?
Offer a very short reply. 0.73. What is the ratio of the Taxes (in $) of Slovenia in 2008 to that in 2009?
Provide a succinct answer. 1.03. What is the ratio of the Taxes (in $) in Zambia in 2008 to that in 2009?
Your answer should be very brief. 1.08. What is the ratio of the Taxes (in $) in China in 2008 to that in 2010?
Your response must be concise. 0.7. What is the ratio of the Taxes (in $) in Nepal in 2008 to that in 2010?
Your answer should be compact. 0.5. What is the ratio of the Taxes (in $) of Slovenia in 2008 to that in 2010?
Keep it short and to the point. 1. What is the ratio of the Taxes (in $) of Zambia in 2008 to that in 2010?
Give a very brief answer. 0.84. What is the ratio of the Taxes (in $) of China in 2008 to that in 2011?
Make the answer very short. 0.6. What is the ratio of the Taxes (in $) of Nepal in 2008 to that in 2011?
Your answer should be very brief. 0.44. What is the ratio of the Taxes (in $) in Slovenia in 2008 to that in 2011?
Keep it short and to the point. 0.99. What is the ratio of the Taxes (in $) of Zambia in 2008 to that in 2011?
Offer a very short reply. 1.03. What is the ratio of the Taxes (in $) in China in 2009 to that in 2010?
Offer a terse response. 0.83. What is the ratio of the Taxes (in $) in Nepal in 2009 to that in 2010?
Make the answer very short. 0.69. What is the ratio of the Taxes (in $) in Slovenia in 2009 to that in 2010?
Give a very brief answer. 0.97. What is the ratio of the Taxes (in $) in Zambia in 2009 to that in 2010?
Your answer should be compact. 0.78. What is the ratio of the Taxes (in $) in China in 2009 to that in 2011?
Provide a short and direct response. 0.71. What is the ratio of the Taxes (in $) in Nepal in 2009 to that in 2011?
Provide a succinct answer. 0.6. What is the ratio of the Taxes (in $) of Slovenia in 2009 to that in 2011?
Offer a very short reply. 0.96. What is the ratio of the Taxes (in $) in Zambia in 2009 to that in 2011?
Your answer should be compact. 0.96. What is the ratio of the Taxes (in $) in China in 2010 to that in 2011?
Your answer should be compact. 0.86. What is the ratio of the Taxes (in $) of Nepal in 2010 to that in 2011?
Give a very brief answer. 0.87. What is the ratio of the Taxes (in $) in Slovenia in 2010 to that in 2011?
Keep it short and to the point. 0.98. What is the ratio of the Taxes (in $) of Zambia in 2010 to that in 2011?
Give a very brief answer. 1.23. What is the difference between the highest and the second highest Taxes (in $) in China?
Make the answer very short. 4.84e+11. What is the difference between the highest and the second highest Taxes (in $) of Nepal?
Provide a short and direct response. 1.25e+1. What is the difference between the highest and the second highest Taxes (in $) of Slovenia?
Keep it short and to the point. 6.41e+07. What is the difference between the highest and the second highest Taxes (in $) in Zambia?
Offer a very short reply. 7.88e+08. What is the difference between the highest and the lowest Taxes (in $) in China?
Your answer should be compact. 2.08e+12. What is the difference between the highest and the lowest Taxes (in $) of Nepal?
Ensure brevity in your answer.  7.05e+1. What is the difference between the highest and the lowest Taxes (in $) in Slovenia?
Ensure brevity in your answer.  9.50e+08. What is the difference between the highest and the lowest Taxes (in $) in Zambia?
Give a very brief answer. 2.56e+09. 